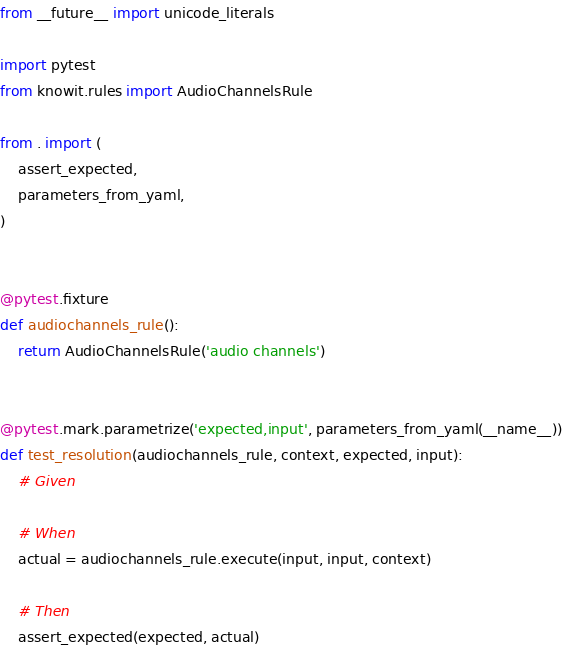Convert code to text. <code><loc_0><loc_0><loc_500><loc_500><_Python_>from __future__ import unicode_literals

import pytest
from knowit.rules import AudioChannelsRule

from . import (
    assert_expected,
    parameters_from_yaml,
)


@pytest.fixture
def audiochannels_rule():
    return AudioChannelsRule('audio channels')


@pytest.mark.parametrize('expected,input', parameters_from_yaml(__name__))
def test_resolution(audiochannels_rule, context, expected, input):
    # Given

    # When
    actual = audiochannels_rule.execute(input, input, context)

    # Then
    assert_expected(expected, actual)
</code> 